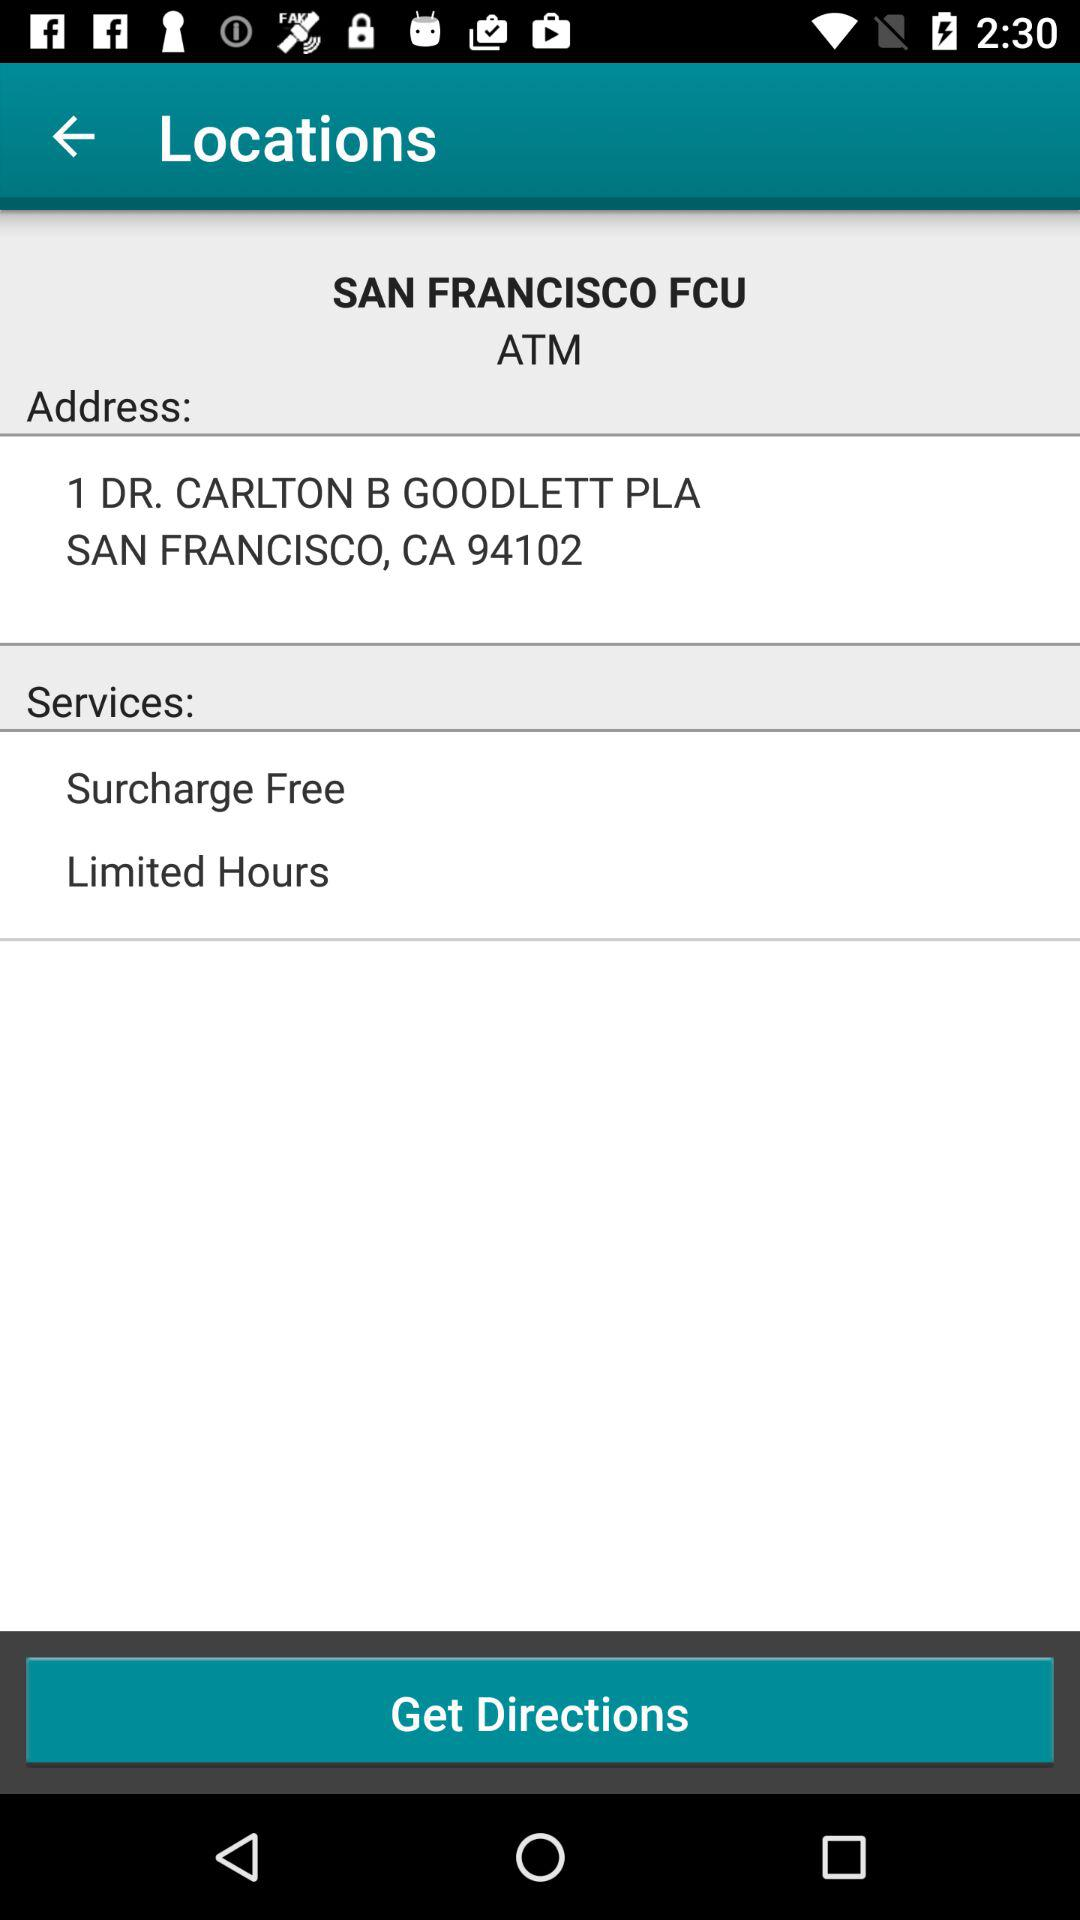How many services are offered at this location?
Answer the question using a single word or phrase. 2 